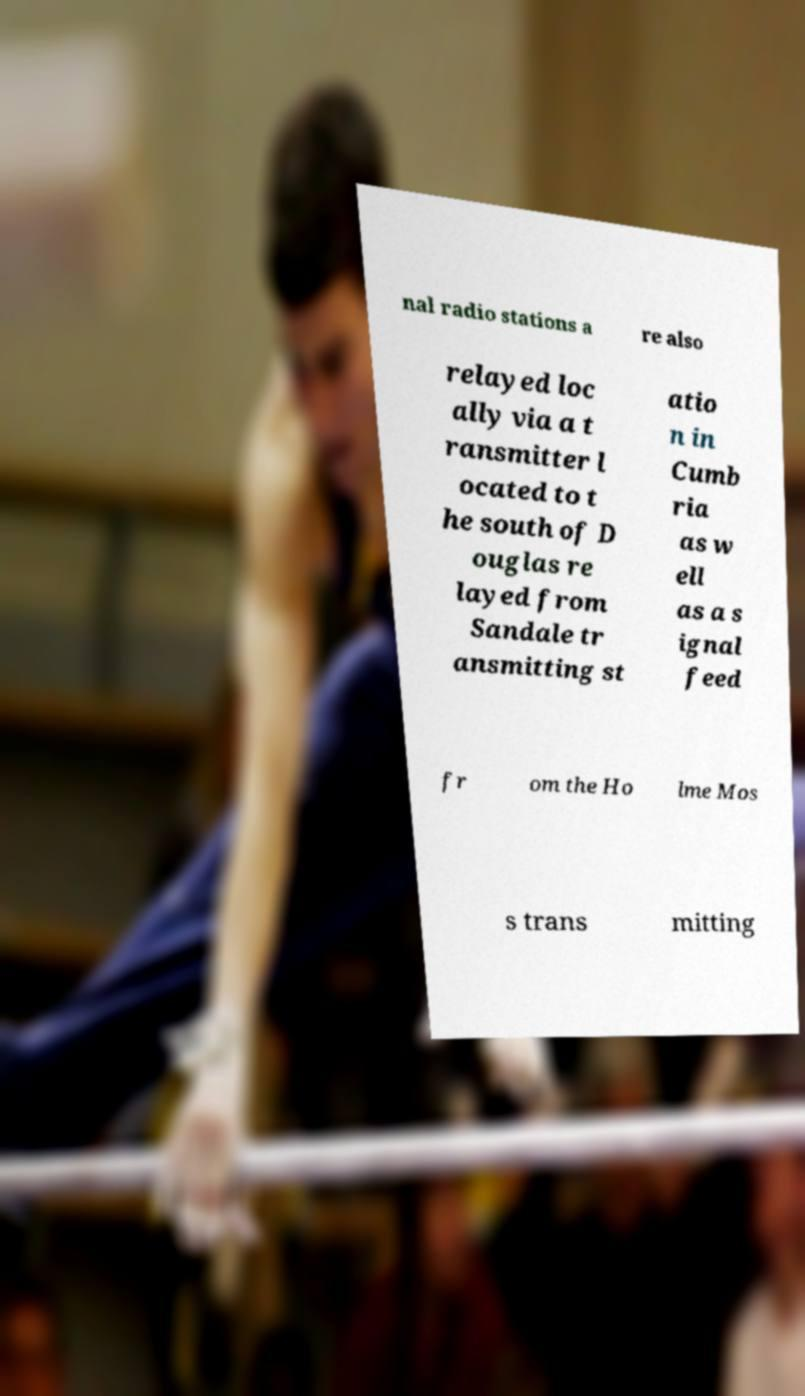There's text embedded in this image that I need extracted. Can you transcribe it verbatim? nal radio stations a re also relayed loc ally via a t ransmitter l ocated to t he south of D ouglas re layed from Sandale tr ansmitting st atio n in Cumb ria as w ell as a s ignal feed fr om the Ho lme Mos s trans mitting 